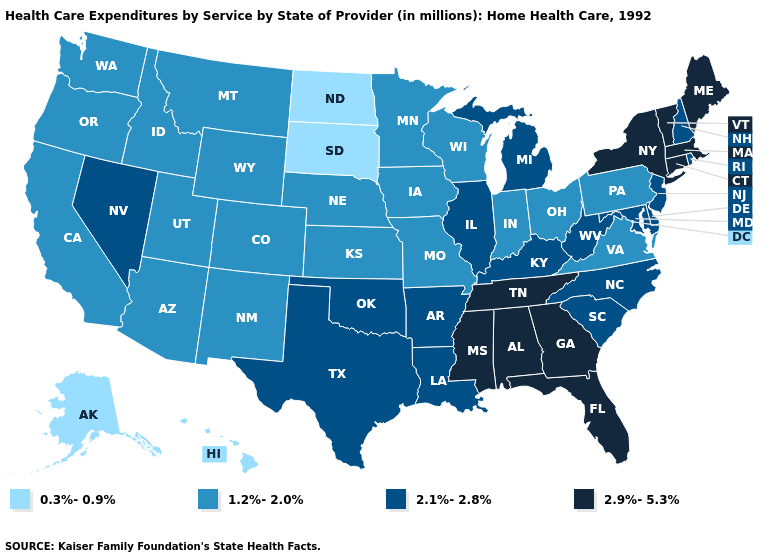What is the value of Wyoming?
Answer briefly. 1.2%-2.0%. Name the states that have a value in the range 2.1%-2.8%?
Give a very brief answer. Arkansas, Delaware, Illinois, Kentucky, Louisiana, Maryland, Michigan, Nevada, New Hampshire, New Jersey, North Carolina, Oklahoma, Rhode Island, South Carolina, Texas, West Virginia. What is the value of Iowa?
Concise answer only. 1.2%-2.0%. What is the highest value in the MidWest ?
Answer briefly. 2.1%-2.8%. What is the lowest value in the USA?
Give a very brief answer. 0.3%-0.9%. Does Louisiana have the lowest value in the USA?
Give a very brief answer. No. What is the value of New York?
Give a very brief answer. 2.9%-5.3%. Does Pennsylvania have the lowest value in the Northeast?
Quick response, please. Yes. Does New Hampshire have the highest value in the Northeast?
Concise answer only. No. Does Idaho have a lower value than Kansas?
Concise answer only. No. Which states have the lowest value in the Northeast?
Concise answer only. Pennsylvania. What is the value of Indiana?
Keep it brief. 1.2%-2.0%. What is the value of New York?
Concise answer only. 2.9%-5.3%. Is the legend a continuous bar?
Short answer required. No. 